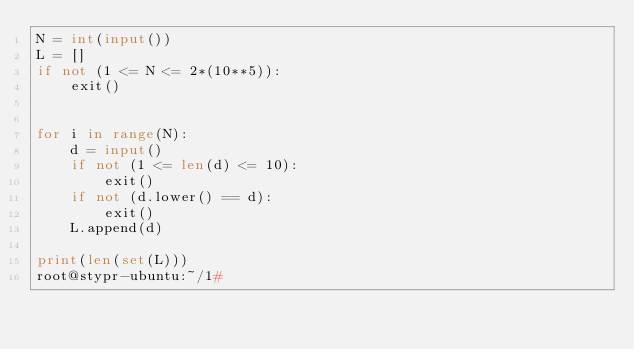<code> <loc_0><loc_0><loc_500><loc_500><_Python_>N = int(input())
L = []
if not (1 <= N <= 2*(10**5)):
    exit()


for i in range(N):
    d = input()
    if not (1 <= len(d) <= 10):
        exit()
    if not (d.lower() == d):
        exit()
    L.append(d)

print(len(set(L)))
root@stypr-ubuntu:~/1# </code> 